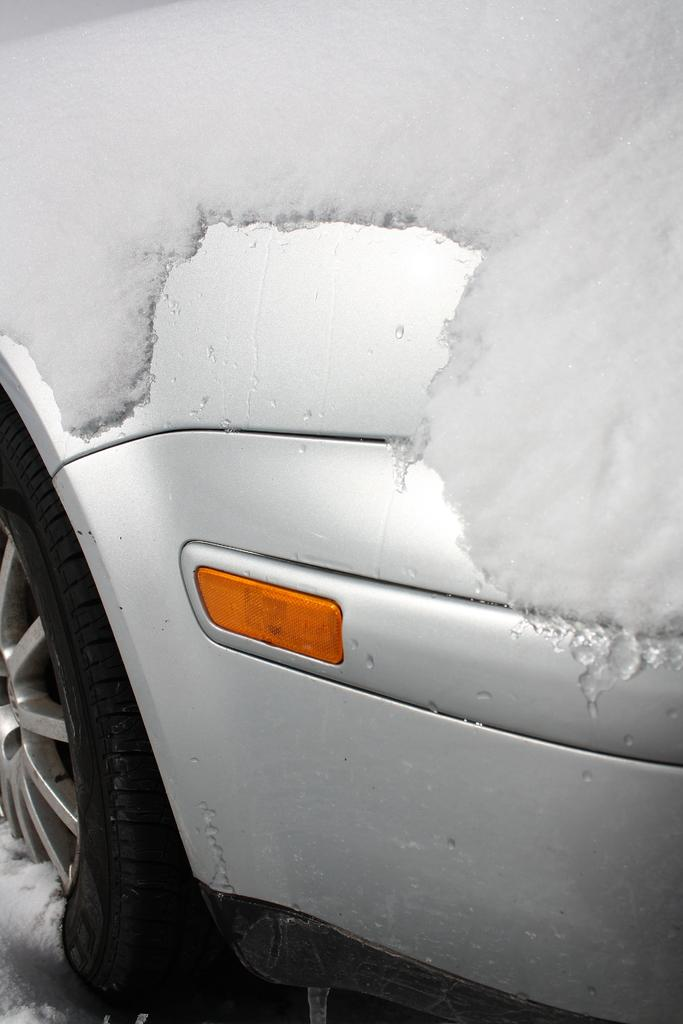What is the main subject of the image? The main subject of the image is a car. How is the car affected by the weather in the image? The car is covered with snow in the image. What type of health advice is being given by the person in the image? There is no person present in the image, so no health advice can be given. 